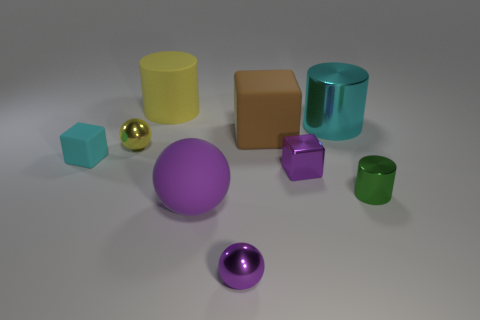Does the tiny metal block have the same color as the big ball?
Provide a short and direct response. Yes. The shiny object that is the same color as the metal block is what size?
Ensure brevity in your answer.  Small. What is the material of the block that is the same color as the rubber ball?
Give a very brief answer. Metal. There is a cyan cylinder; are there any small green metal objects in front of it?
Provide a succinct answer. Yes. Does the large cylinder to the right of the large brown rubber block have the same material as the large brown block?
Your answer should be very brief. No. Is there a large matte ball that has the same color as the tiny metal block?
Ensure brevity in your answer.  Yes. The purple matte thing is what shape?
Offer a very short reply. Sphere. There is a matte block that is on the left side of the small purple shiny thing in front of the big purple matte thing; what color is it?
Keep it short and to the point. Cyan. There is a shiny cylinder that is to the left of the green metallic cylinder; how big is it?
Your answer should be very brief. Large. Is there a big gray block that has the same material as the small cyan object?
Your response must be concise. No. 